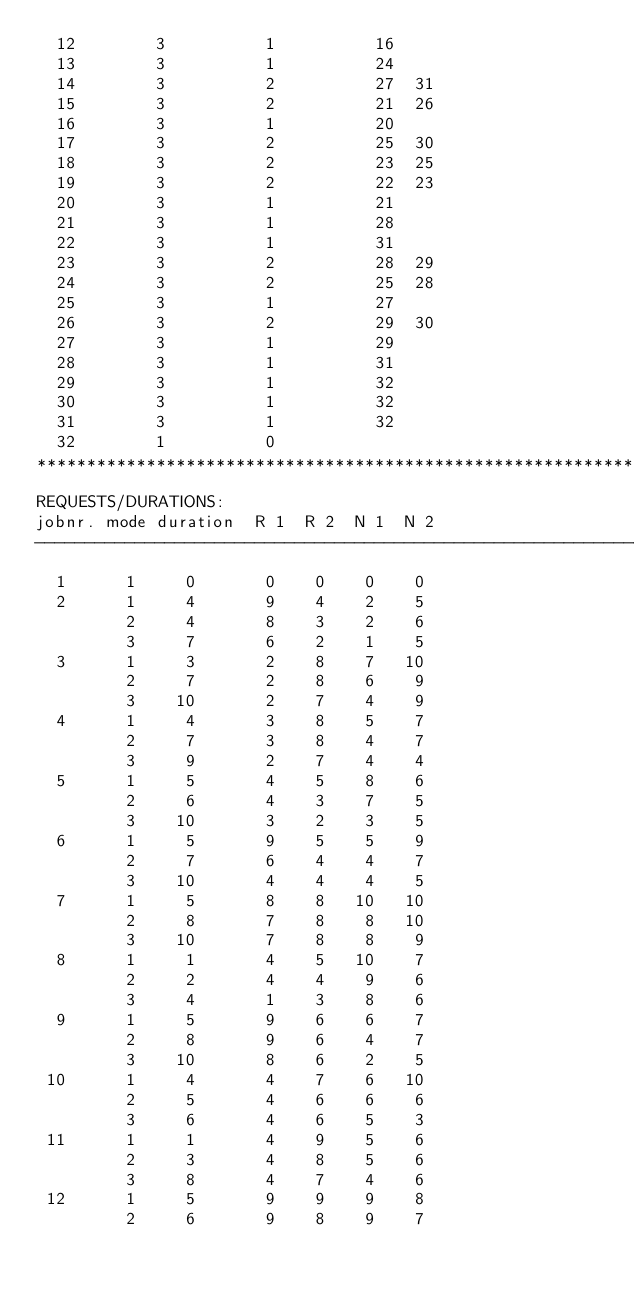Convert code to text. <code><loc_0><loc_0><loc_500><loc_500><_ObjectiveC_>  12        3          1          16
  13        3          1          24
  14        3          2          27  31
  15        3          2          21  26
  16        3          1          20
  17        3          2          25  30
  18        3          2          23  25
  19        3          2          22  23
  20        3          1          21
  21        3          1          28
  22        3          1          31
  23        3          2          28  29
  24        3          2          25  28
  25        3          1          27
  26        3          2          29  30
  27        3          1          29
  28        3          1          31
  29        3          1          32
  30        3          1          32
  31        3          1          32
  32        1          0        
************************************************************************
REQUESTS/DURATIONS:
jobnr. mode duration  R 1  R 2  N 1  N 2
------------------------------------------------------------------------
  1      1     0       0    0    0    0
  2      1     4       9    4    2    5
         2     4       8    3    2    6
         3     7       6    2    1    5
  3      1     3       2    8    7   10
         2     7       2    8    6    9
         3    10       2    7    4    9
  4      1     4       3    8    5    7
         2     7       3    8    4    7
         3     9       2    7    4    4
  5      1     5       4    5    8    6
         2     6       4    3    7    5
         3    10       3    2    3    5
  6      1     5       9    5    5    9
         2     7       6    4    4    7
         3    10       4    4    4    5
  7      1     5       8    8   10   10
         2     8       7    8    8   10
         3    10       7    8    8    9
  8      1     1       4    5   10    7
         2     2       4    4    9    6
         3     4       1    3    8    6
  9      1     5       9    6    6    7
         2     8       9    6    4    7
         3    10       8    6    2    5
 10      1     4       4    7    6   10
         2     5       4    6    6    6
         3     6       4    6    5    3
 11      1     1       4    9    5    6
         2     3       4    8    5    6
         3     8       4    7    4    6
 12      1     5       9    9    9    8
         2     6       9    8    9    7</code> 